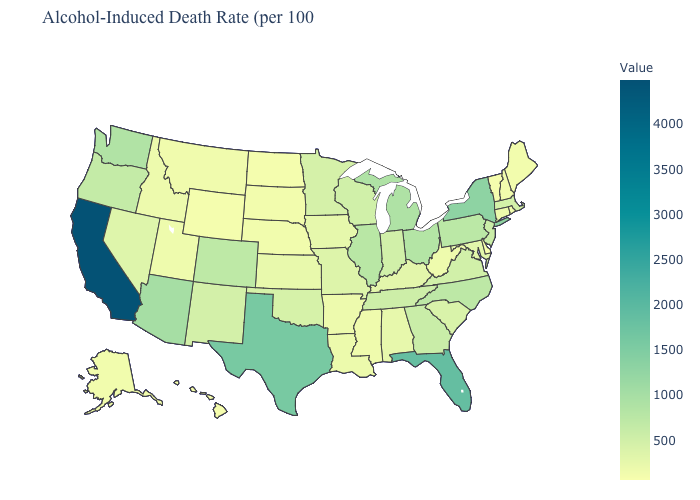Which states have the lowest value in the USA?
Give a very brief answer. Delaware. Among the states that border Oklahoma , which have the lowest value?
Be succinct. Arkansas. Is the legend a continuous bar?
Quick response, please. Yes. Among the states that border Missouri , does Nebraska have the lowest value?
Quick response, please. Yes. Is the legend a continuous bar?
Quick response, please. Yes. Does Michigan have the highest value in the MidWest?
Keep it brief. Yes. 